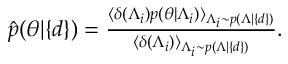<formula> <loc_0><loc_0><loc_500><loc_500>\begin{array} { r } { \hat { p } ( \theta | \{ d \} ) = \frac { \langle \delta ( \Lambda _ { i } ) p ( \theta | \Lambda _ { i } ) \rangle _ { \Lambda _ { i } \sim p ( \Lambda | \{ d \} ) } } { \langle \delta ( \Lambda _ { i } ) \rangle _ { \Lambda _ { i } \sim p ( \Lambda | \{ d \} ) } } . } \end{array}</formula> 